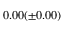<formula> <loc_0><loc_0><loc_500><loc_500>0 . 0 0 ( \pm 0 . 0 0 ) \</formula> 